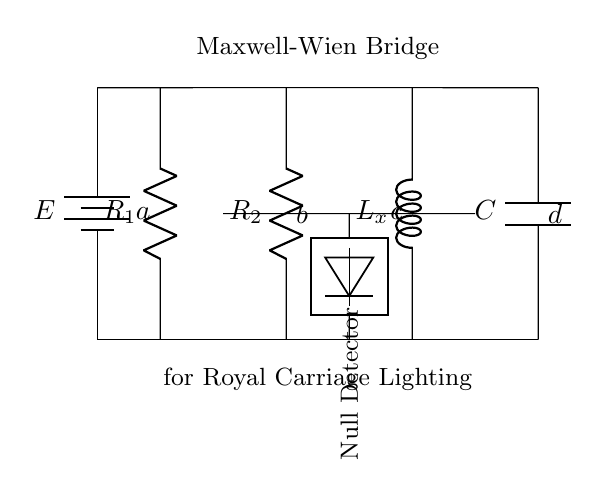What type of bridge is depicted in the circuit? The circuit diagram shows a Maxwell-Wien Bridge, which is specifically designed for measuring inductance. This can be inferred from the labeling within the diagram.
Answer: Maxwell-Wien Bridge What is the component labeled L_x used for? The component L_x in the circuit represents an inductor, which is the primary element that the bridge aims to measure. The label indicates its function as a variable in the measurement setup.
Answer: Inductor How many resistors are in the circuit? There are two resistors in the circuit as shown by the labels R_1 and R_2 attached to respective vertical lines in the diagram.
Answer: Two What does the null detector in the circuit measure? The null detector is used to indicate when the bridge is balanced, which implies that the voltages across certain points are equal. This measurement is crucial for determining the inductance accurately.
Answer: Voltage balance What happens when the bridge is balanced? When the bridge is balanced, it means that the current through the null detector is zero, allowing for precise measurement of the unknown inductance L_x. This can be inferred from the functioning of the bridge setup.
Answer: Current is zero What role does the battery play in this circuit? The battery in the circuit provides the necessary voltage to drive current through the components, creating a potential difference crucial for the operation of the bridge and the detection of null conditions.
Answer: Provides voltage 